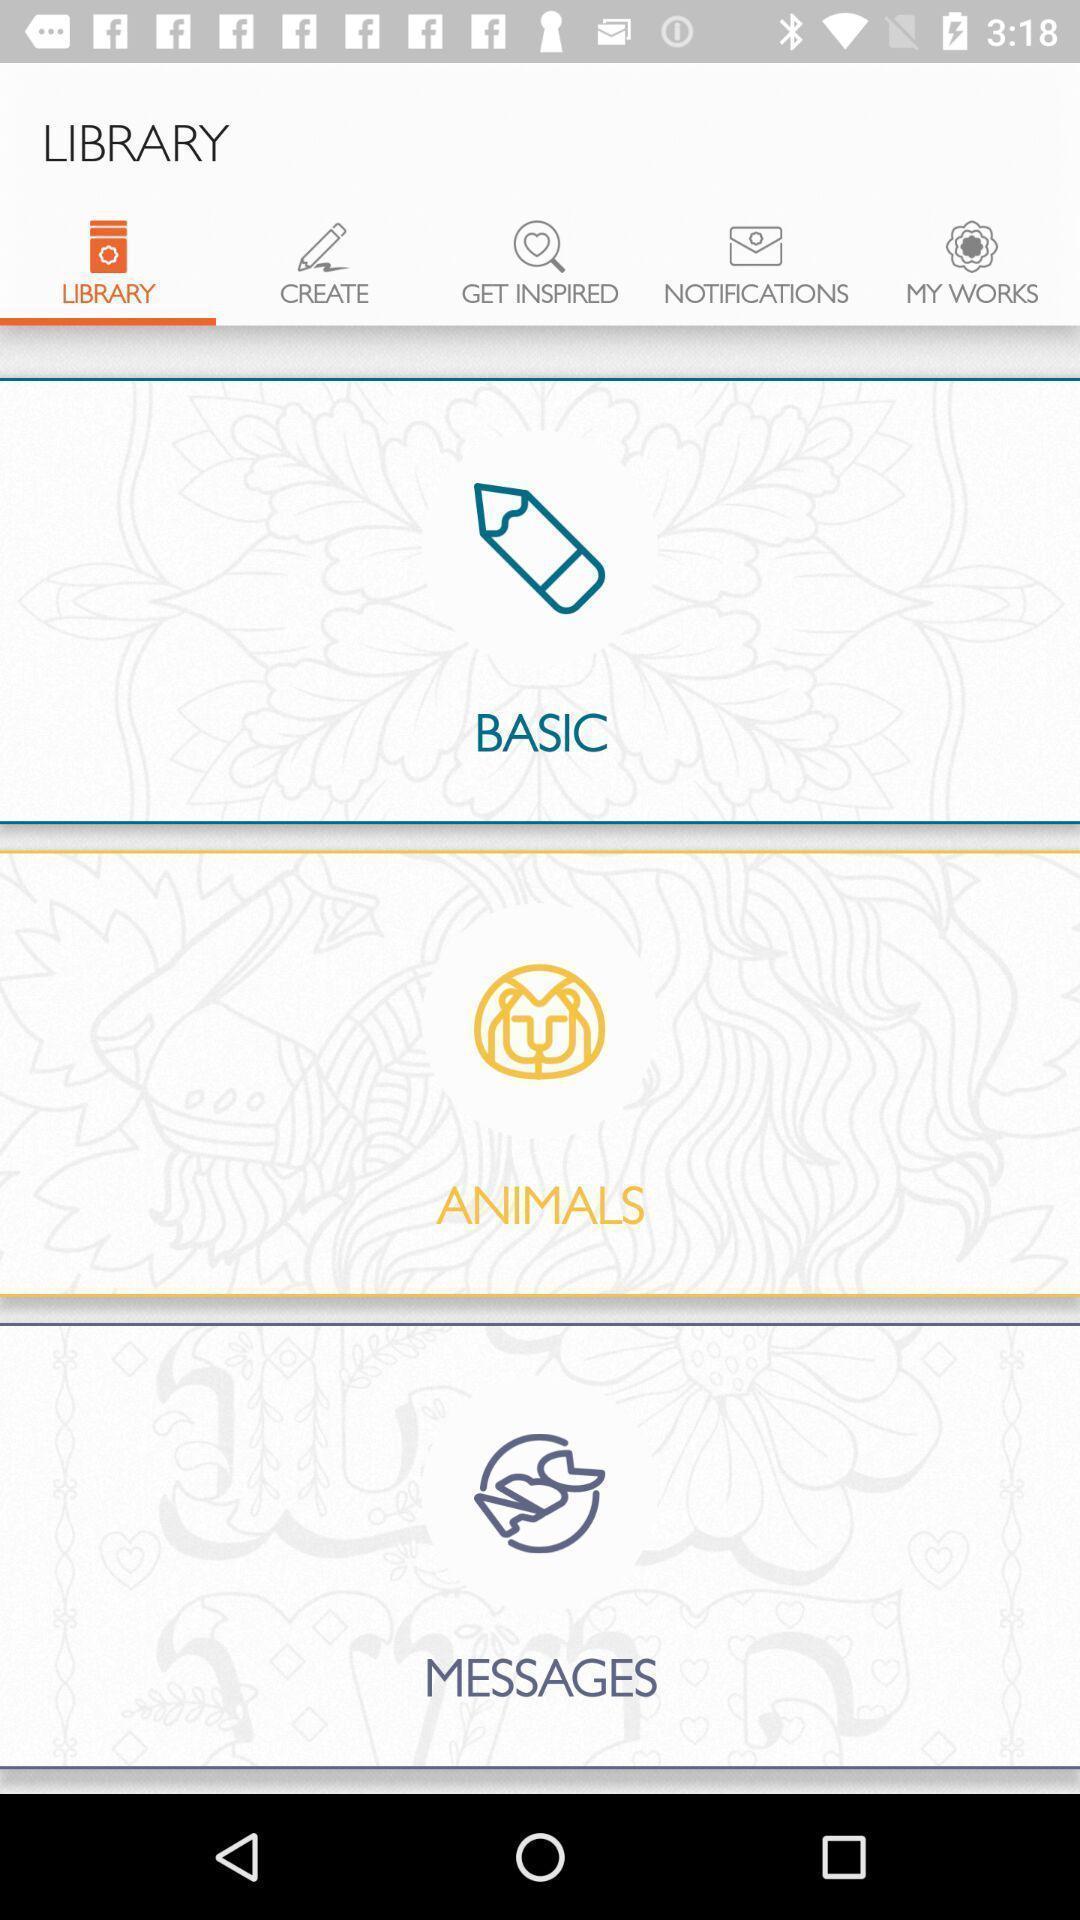Summarize the information in this screenshot. Screen showing library. 